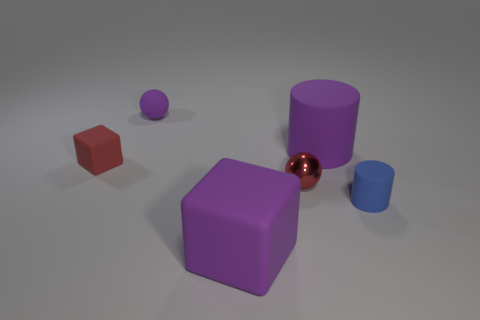What is the color of the small metal object?
Provide a succinct answer. Red. What is the material of the cube that is the same color as the metal object?
Keep it short and to the point. Rubber. Are there any large purple rubber things of the same shape as the blue rubber object?
Give a very brief answer. Yes. There is a purple thing that is in front of the tiny cube; what size is it?
Ensure brevity in your answer.  Large. There is a purple cylinder that is the same size as the purple matte cube; what is its material?
Provide a short and direct response. Rubber. Are there more tiny matte cubes than tiny gray cylinders?
Your answer should be very brief. Yes. There is a cube that is behind the large rubber thing in front of the big cylinder; what size is it?
Your response must be concise. Small. The purple object that is the same size as the purple cube is what shape?
Offer a terse response. Cylinder. The large rubber thing behind the small sphere that is on the right side of the tiny ball behind the red cube is what shape?
Offer a terse response. Cylinder. There is a big rubber thing that is in front of the big purple matte cylinder; does it have the same color as the big object behind the small block?
Provide a short and direct response. Yes. 